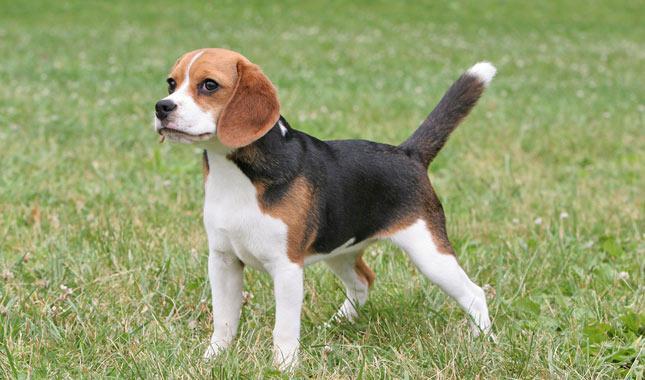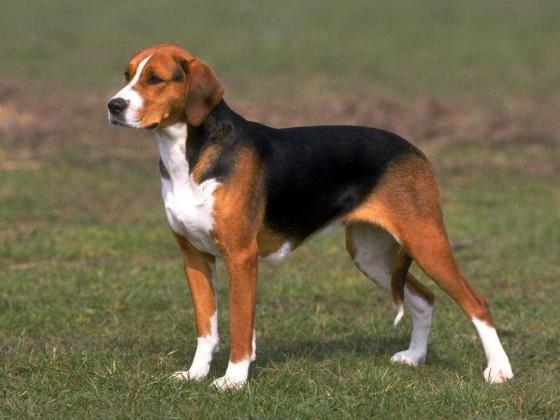The first image is the image on the left, the second image is the image on the right. Given the left and right images, does the statement "At least one dog is sitting." hold true? Answer yes or no. No. 